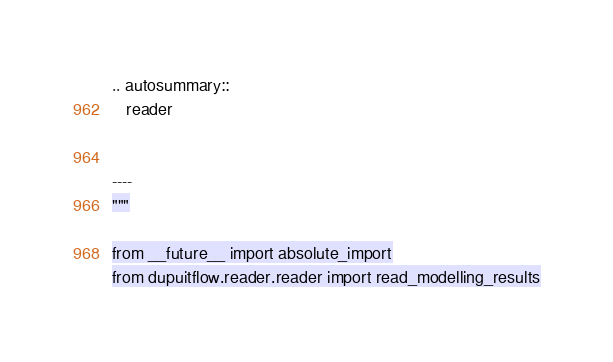Convert code to text. <code><loc_0><loc_0><loc_500><loc_500><_Python_>
.. autosummary::
   reader


----
"""

from __future__ import absolute_import
from dupuitflow.reader.reader import read_modelling_results
</code> 